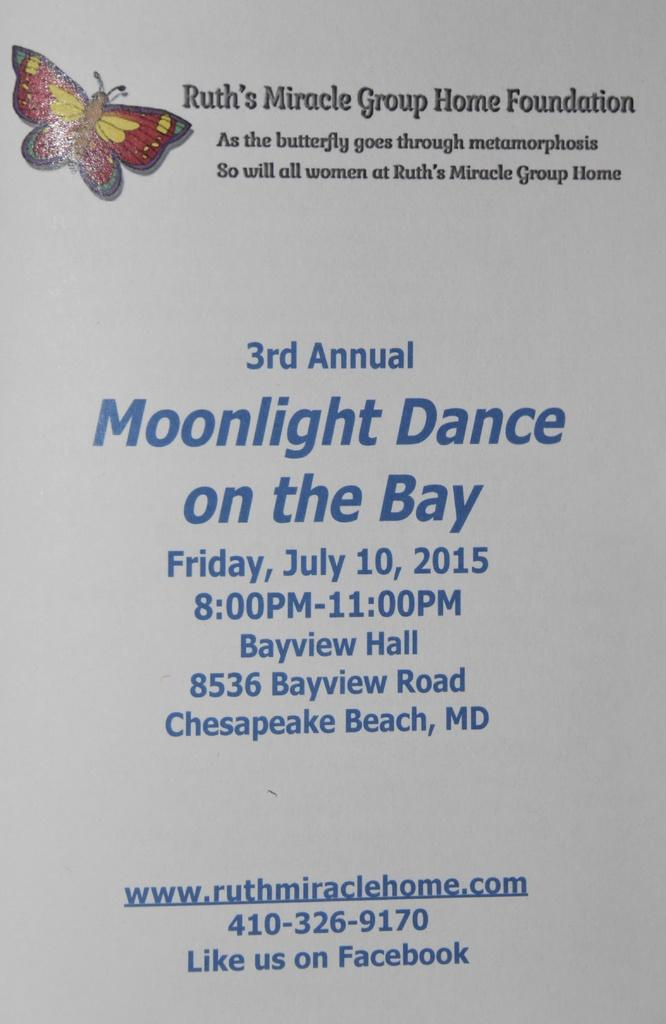What is present in the picture? There is a poster in the picture. What can be found on the poster? The poster has some text. Is there anything else visible in the picture? Yes, there is a butterfly at the top left corner of the picture. What type of soup is being served to the boys in the picture? There are no boys or soup present in the picture; it only features a poster and a butterfly. 